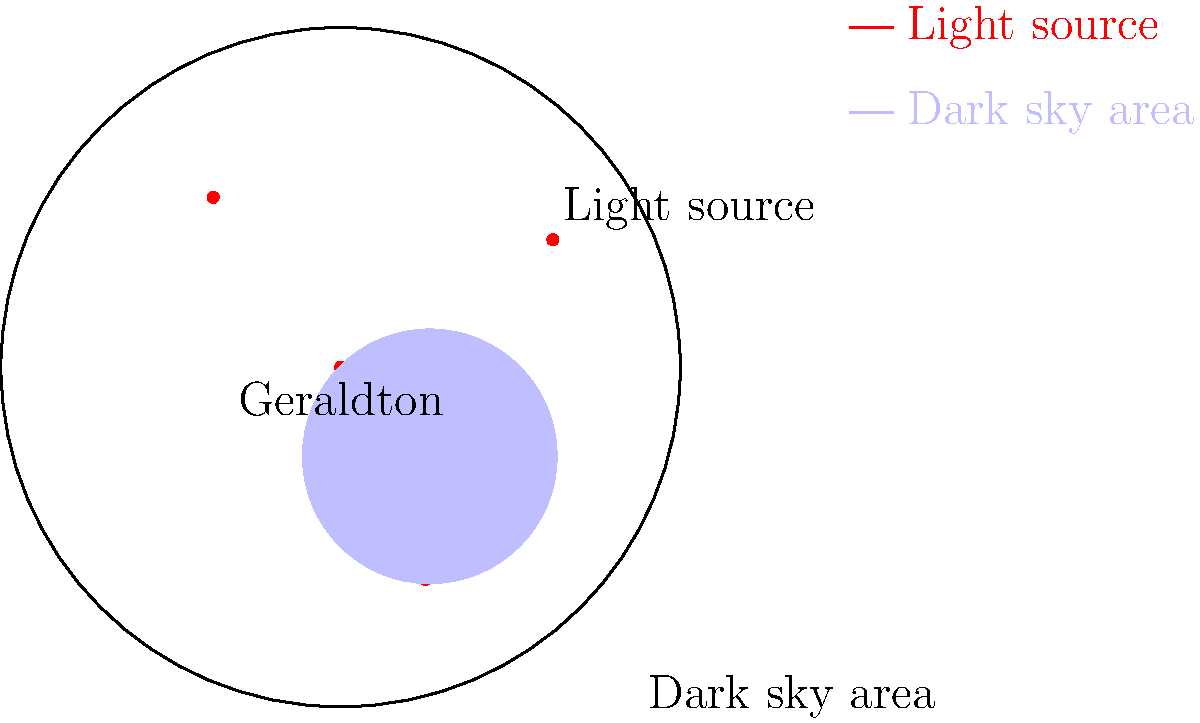Based on the map of Geraldton showing light sources and a potential dark sky area, what is the most effective strategy to minimize light pollution's impact on stargazing activities? To determine the most effective strategy to minimize light pollution's impact on stargazing in Geraldton, let's analyze the map and consider the principles of light pollution mitigation:

1. Light source distribution: The map shows multiple light sources scattered throughout Geraldton, indicating widespread urban lighting.

2. Dark sky area: A potential dark sky area is identified in the southeastern part of the map, away from the main light sources.

3. Light pollution principles:
   a) Distance from light sources reduces their impact.
   b) Shielding and directing lights downward can significantly reduce sky glow.
   c) Using warmer color temperatures (e.g., amber) and dimmer lights can minimize impact on wildlife and improve stargazing conditions.

4. Effective strategies:
   a) Establish the identified dark sky area as a designated stargazing zone.
   b) Implement lighting ordinances in Geraldton to require shielded, downward-facing lights.
   c) Gradually replace existing lights with warmer color temperature LEDs.
   d) Encourage the use of timers and motion sensors to reduce unnecessary lighting.

5. Most effective approach: A combination of creating a protected dark sky area and implementing city-wide lighting improvements.

Given the distribution of light sources and the presence of a potential dark sky area, the most effective strategy would be to establish the southeastern area as a designated dark sky reserve while simultaneously working on city-wide lighting improvements. This dual approach addresses both immediate stargazing needs and long-term light pollution reduction.
Answer: Establish a dark sky reserve and implement city-wide lighting improvements. 